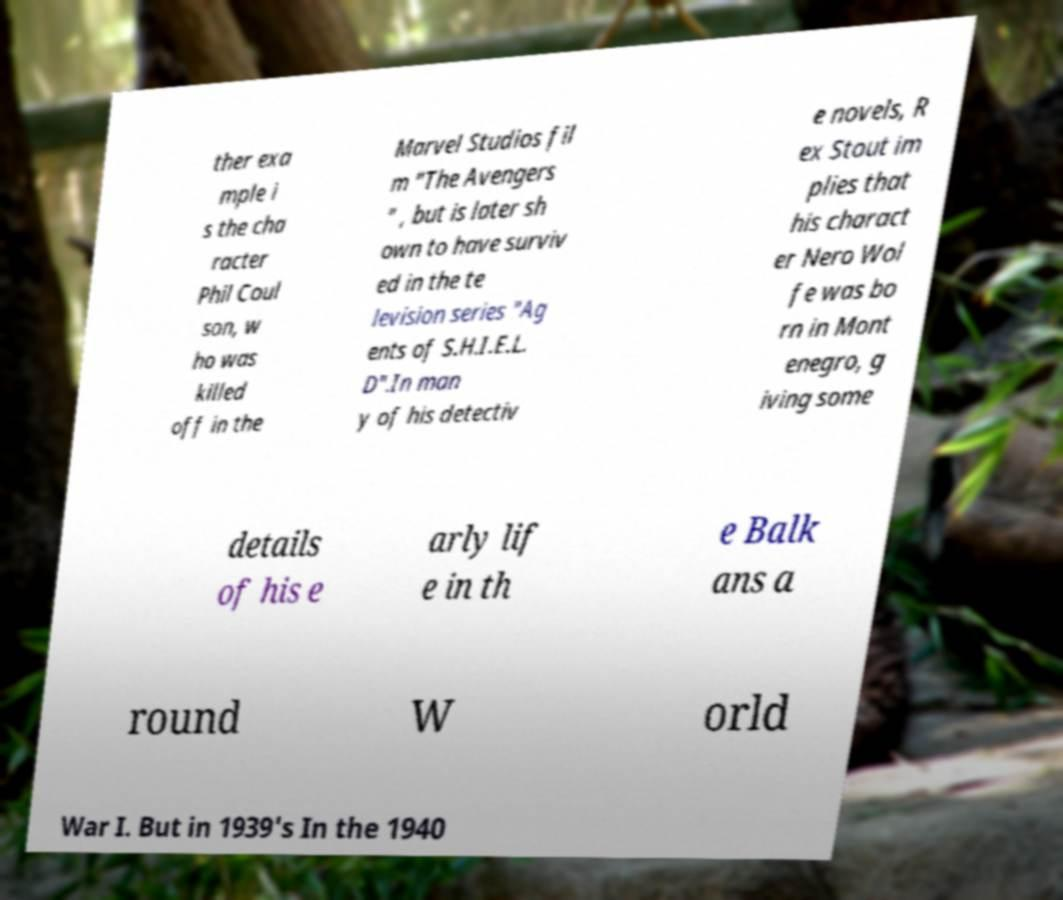What messages or text are displayed in this image? I need them in a readable, typed format. ther exa mple i s the cha racter Phil Coul son, w ho was killed off in the Marvel Studios fil m "The Avengers " , but is later sh own to have surviv ed in the te levision series "Ag ents of S.H.I.E.L. D".In man y of his detectiv e novels, R ex Stout im plies that his charact er Nero Wol fe was bo rn in Mont enegro, g iving some details of his e arly lif e in th e Balk ans a round W orld War I. But in 1939's In the 1940 